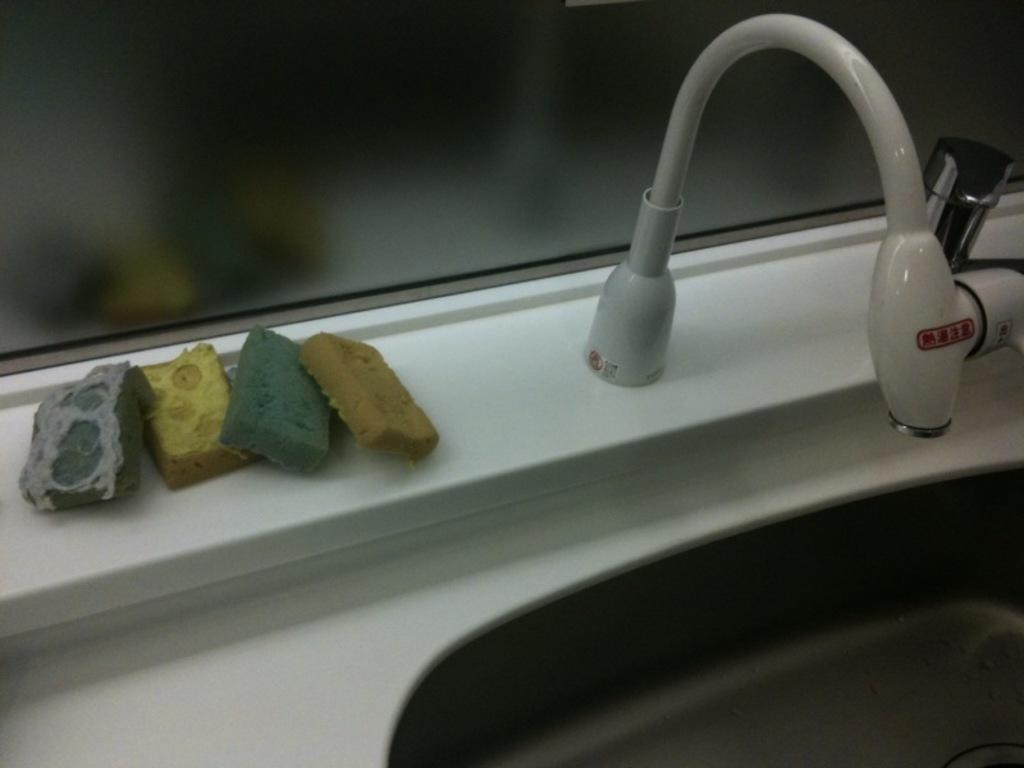What is the primary fixture in the image? There is a sink in the image. What is attached to the sink? There is a tap in the image. Can you describe any other objects present in the image? Yes, there are other objects in the image. What type of weather can be seen in the image? There is no weather visible in the image, as it is focused on a sink and a tap. What shape is the sink in the image? The provided facts do not give us enough information to determine the shape of the sink. 